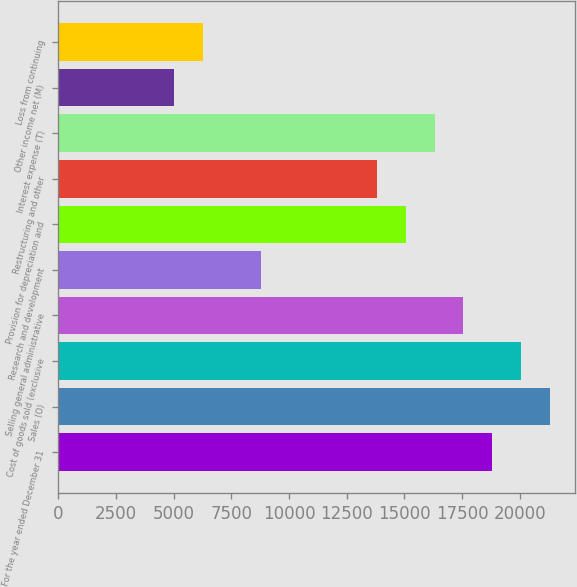<chart> <loc_0><loc_0><loc_500><loc_500><bar_chart><fcel>For the year ended December 31<fcel>Sales (O)<fcel>Cost of goods sold (exclusive<fcel>Selling general administrative<fcel>Research and development<fcel>Provision for depreciation and<fcel>Restructuring and other<fcel>Interest expense (T)<fcel>Other income net (M)<fcel>Loss from continuing<nl><fcel>18812.9<fcel>21321.3<fcel>20067.1<fcel>17558.7<fcel>8779.47<fcel>15050.4<fcel>13796.2<fcel>16304.5<fcel>5016.93<fcel>6271.11<nl></chart> 